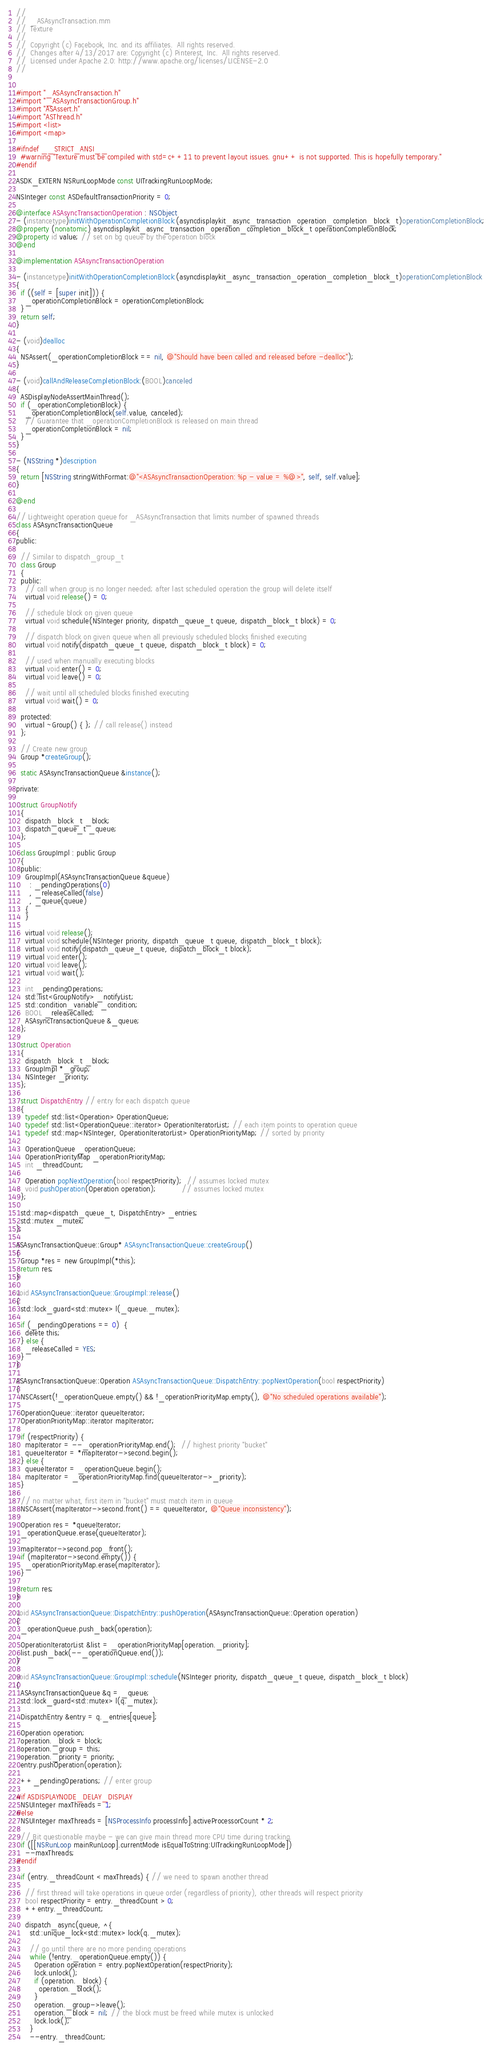<code> <loc_0><loc_0><loc_500><loc_500><_ObjectiveC_>//
//  _ASAsyncTransaction.mm
//  Texture
//
//  Copyright (c) Facebook, Inc. and its affiliates.  All rights reserved.
//  Changes after 4/13/2017 are: Copyright (c) Pinterest, Inc.  All rights reserved.
//  Licensed under Apache 2.0: http://www.apache.org/licenses/LICENSE-2.0
//


#import "_ASAsyncTransaction.h"
#import "_ASAsyncTransactionGroup.h"
#import "ASAssert.h"
#import "ASThread.h"
#import <list>
#import <map>

#ifndef __STRICT_ANSI__
  #warning "Texture must be compiled with std=c++11 to prevent layout issues. gnu++ is not supported. This is hopefully temporary."
#endif

ASDK_EXTERN NSRunLoopMode const UITrackingRunLoopMode;

NSInteger const ASDefaultTransactionPriority = 0;

@interface ASAsyncTransactionOperation : NSObject
- (instancetype)initWithOperationCompletionBlock:(asyncdisplaykit_async_transaction_operation_completion_block_t)operationCompletionBlock;
@property (nonatomic) asyncdisplaykit_async_transaction_operation_completion_block_t operationCompletionBlock;
@property id value; // set on bg queue by the operation block
@end

@implementation ASAsyncTransactionOperation

- (instancetype)initWithOperationCompletionBlock:(asyncdisplaykit_async_transaction_operation_completion_block_t)operationCompletionBlock
{
  if ((self = [super init])) {
    _operationCompletionBlock = operationCompletionBlock;
  }
  return self;
}

- (void)dealloc
{
  NSAssert(_operationCompletionBlock == nil, @"Should have been called and released before -dealloc");
}

- (void)callAndReleaseCompletionBlock:(BOOL)canceled
{
  ASDisplayNodeAssertMainThread();
  if (_operationCompletionBlock) {
    _operationCompletionBlock(self.value, canceled);
    // Guarantee that _operationCompletionBlock is released on main thread
    _operationCompletionBlock = nil;
  }
}

- (NSString *)description
{
  return [NSString stringWithFormat:@"<ASAsyncTransactionOperation: %p - value = %@>", self, self.value];
}

@end

// Lightweight operation queue for _ASAsyncTransaction that limits number of spawned threads
class ASAsyncTransactionQueue
{
public:
  
  // Similar to dispatch_group_t
  class Group
  {
  public:
    // call when group is no longer needed; after last scheduled operation the group will delete itself
    virtual void release() = 0;
    
    // schedule block on given queue
    virtual void schedule(NSInteger priority, dispatch_queue_t queue, dispatch_block_t block) = 0;
    
    // dispatch block on given queue when all previously scheduled blocks finished executing
    virtual void notify(dispatch_queue_t queue, dispatch_block_t block) = 0;
    
    // used when manually executing blocks
    virtual void enter() = 0;
    virtual void leave() = 0;
    
    // wait until all scheduled blocks finished executing
    virtual void wait() = 0;
    
  protected:
    virtual ~Group() { }; // call release() instead
  };
  
  // Create new group
  Group *createGroup();
  
  static ASAsyncTransactionQueue &instance();
  
private:
  
  struct GroupNotify
  {
    dispatch_block_t _block;
    dispatch_queue_t _queue;
  };
  
  class GroupImpl : public Group
  {
  public:
    GroupImpl(ASAsyncTransactionQueue &queue)
      : _pendingOperations(0)
      , _releaseCalled(false)
      , _queue(queue)
    {
    }
    
    virtual void release();
    virtual void schedule(NSInteger priority, dispatch_queue_t queue, dispatch_block_t block);
    virtual void notify(dispatch_queue_t queue, dispatch_block_t block);
    virtual void enter();
    virtual void leave();
    virtual void wait();
    
    int _pendingOperations;
    std::list<GroupNotify> _notifyList;
    std::condition_variable _condition;
    BOOL _releaseCalled;
    ASAsyncTransactionQueue &_queue;
  };
  
  struct Operation
  {
    dispatch_block_t _block;
    GroupImpl *_group;
    NSInteger _priority;
  };
    
  struct DispatchEntry // entry for each dispatch queue
  {
    typedef std::list<Operation> OperationQueue;
    typedef std::list<OperationQueue::iterator> OperationIteratorList; // each item points to operation queue
    typedef std::map<NSInteger, OperationIteratorList> OperationPriorityMap; // sorted by priority

    OperationQueue _operationQueue;
    OperationPriorityMap _operationPriorityMap;
    int _threadCount;
      
    Operation popNextOperation(bool respectPriority);  // assumes locked mutex
    void pushOperation(Operation operation);           // assumes locked mutex
  };
  
  std::map<dispatch_queue_t, DispatchEntry> _entries;
  std::mutex _mutex;
};

ASAsyncTransactionQueue::Group* ASAsyncTransactionQueue::createGroup()
{
  Group *res = new GroupImpl(*this);
  return res;
}

void ASAsyncTransactionQueue::GroupImpl::release()
{
  std::lock_guard<std::mutex> l(_queue._mutex);
  
  if (_pendingOperations == 0)  {
    delete this;
  } else {
    _releaseCalled = YES;
  }
}

ASAsyncTransactionQueue::Operation ASAsyncTransactionQueue::DispatchEntry::popNextOperation(bool respectPriority)
{
  NSCAssert(!_operationQueue.empty() && !_operationPriorityMap.empty(), @"No scheduled operations available");

  OperationQueue::iterator queueIterator;
  OperationPriorityMap::iterator mapIterator;
  
  if (respectPriority) {
    mapIterator = --_operationPriorityMap.end();  // highest priority "bucket"
    queueIterator = *mapIterator->second.begin();
  } else {
    queueIterator = _operationQueue.begin();
    mapIterator = _operationPriorityMap.find(queueIterator->_priority);
  }
  
  // no matter what, first item in "bucket" must match item in queue
  NSCAssert(mapIterator->second.front() == queueIterator, @"Queue inconsistency");
  
  Operation res = *queueIterator;
  _operationQueue.erase(queueIterator);
  
  mapIterator->second.pop_front();
  if (mapIterator->second.empty()) {
    _operationPriorityMap.erase(mapIterator);
  }

  return res;
}

void ASAsyncTransactionQueue::DispatchEntry::pushOperation(ASAsyncTransactionQueue::Operation operation)
{
  _operationQueue.push_back(operation);

  OperationIteratorList &list = _operationPriorityMap[operation._priority];
  list.push_back(--_operationQueue.end());
}

void ASAsyncTransactionQueue::GroupImpl::schedule(NSInteger priority, dispatch_queue_t queue, dispatch_block_t block)
{
  ASAsyncTransactionQueue &q = _queue;
  std::lock_guard<std::mutex> l(q._mutex);
  
  DispatchEntry &entry = q._entries[queue];
  
  Operation operation;
  operation._block = block;
  operation._group = this;
  operation._priority = priority;
  entry.pushOperation(operation);
  
  ++_pendingOperations; // enter group
  
#if ASDISPLAYNODE_DELAY_DISPLAY
  NSUInteger maxThreads = 1;
#else 
  NSUInteger maxThreads = [NSProcessInfo processInfo].activeProcessorCount * 2;

  // Bit questionable maybe - we can give main thread more CPU time during tracking.
  if ([[NSRunLoop mainRunLoop].currentMode isEqualToString:UITrackingRunLoopMode])
    --maxThreads;
#endif
  
  if (entry._threadCount < maxThreads) { // we need to spawn another thread

    // first thread will take operations in queue order (regardless of priority), other threads will respect priority
    bool respectPriority = entry._threadCount > 0;
    ++entry._threadCount;
    
    dispatch_async(queue, ^{
      std::unique_lock<std::mutex> lock(q._mutex);
      
      // go until there are no more pending operations
      while (!entry._operationQueue.empty()) {
        Operation operation = entry.popNextOperation(respectPriority);
        lock.unlock();
        if (operation._block) {
          operation._block();
        }
        operation._group->leave();
        operation._block = nil; // the block must be freed while mutex is unlocked
        lock.lock();
      }
      --entry._threadCount;</code> 